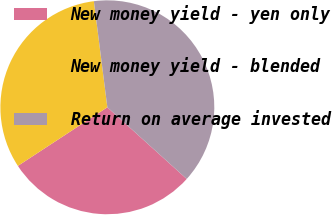Convert chart. <chart><loc_0><loc_0><loc_500><loc_500><pie_chart><fcel>New money yield - yen only<fcel>New money yield - blended<fcel>Return on average invested<nl><fcel>29.08%<fcel>32.22%<fcel>38.7%<nl></chart> 